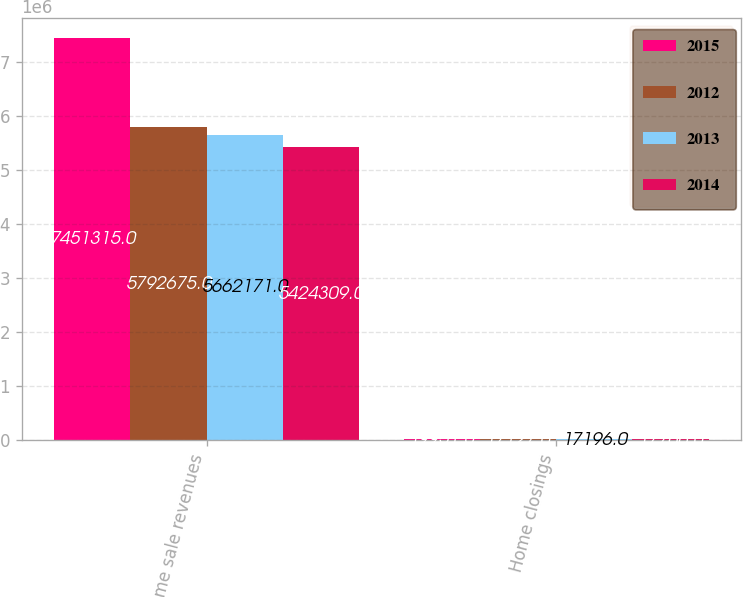Convert chart to OTSL. <chart><loc_0><loc_0><loc_500><loc_500><stacked_bar_chart><ecel><fcel>Home sale revenues<fcel>Home closings<nl><fcel>2015<fcel>7.45132e+06<fcel>19951<nl><fcel>2012<fcel>5.79268e+06<fcel>17127<nl><fcel>2013<fcel>5.66217e+06<fcel>17196<nl><fcel>2014<fcel>5.42431e+06<fcel>17766<nl></chart> 